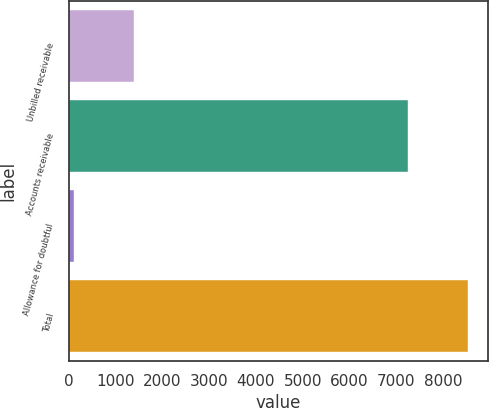<chart> <loc_0><loc_0><loc_500><loc_500><bar_chart><fcel>Unbilled receivable<fcel>Accounts receivable<fcel>Allowance for doubtful<fcel>Total<nl><fcel>1396<fcel>7251<fcel>109<fcel>8538<nl></chart> 